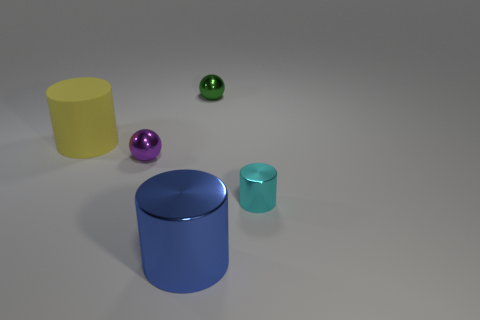How many yellow matte cylinders are the same size as the blue metal cylinder?
Your answer should be very brief. 1. Are there the same number of green shiny things that are to the right of the green shiny thing and tiny green metal objects?
Keep it short and to the point. No. What number of things are both in front of the green shiny sphere and on the right side of the yellow thing?
Provide a succinct answer. 3. What size is the cyan thing that is made of the same material as the green object?
Your response must be concise. Small. How many other matte things are the same shape as the green thing?
Offer a very short reply. 0. Are there more large yellow objects that are in front of the tiny cyan shiny object than things?
Your response must be concise. No. The object that is on the left side of the big blue shiny thing and on the right side of the large yellow rubber cylinder has what shape?
Give a very brief answer. Sphere. Is the size of the cyan cylinder the same as the green sphere?
Your response must be concise. Yes. How many cyan metal cylinders are behind the cyan object?
Offer a very short reply. 0. Are there the same number of large blue shiny things behind the purple object and large cylinders that are to the right of the tiny cyan metallic cylinder?
Make the answer very short. Yes. 